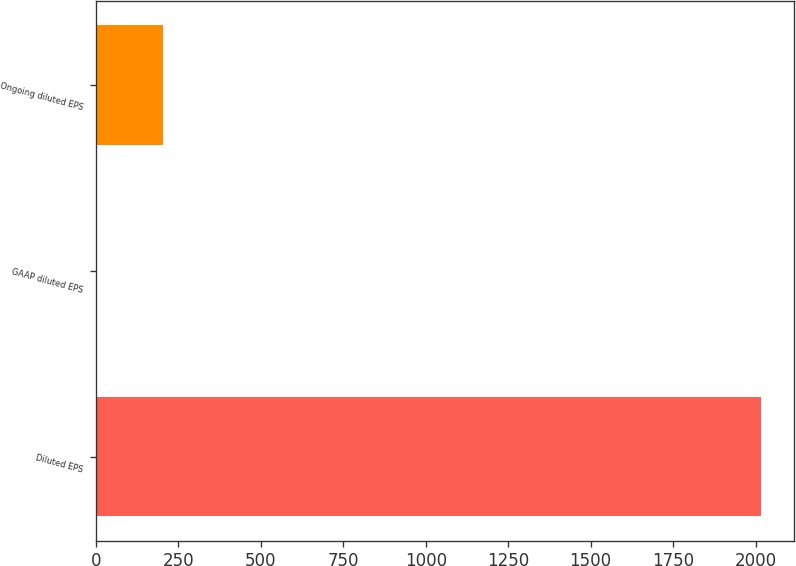Convert chart. <chart><loc_0><loc_0><loc_500><loc_500><bar_chart><fcel>Diluted EPS<fcel>GAAP diluted EPS<fcel>Ongoing diluted EPS<nl><fcel>2016<fcel>2.21<fcel>203.59<nl></chart> 